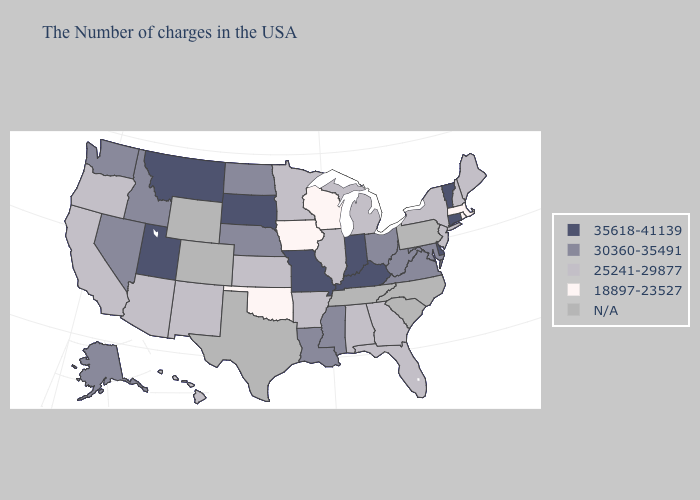Name the states that have a value in the range 35618-41139?
Quick response, please. Vermont, Connecticut, Delaware, Kentucky, Indiana, Missouri, South Dakota, Utah, Montana. Name the states that have a value in the range N/A?
Write a very short answer. Pennsylvania, North Carolina, South Carolina, Tennessee, Texas, Wyoming, Colorado. Does the map have missing data?
Keep it brief. Yes. Name the states that have a value in the range 35618-41139?
Short answer required. Vermont, Connecticut, Delaware, Kentucky, Indiana, Missouri, South Dakota, Utah, Montana. Which states have the highest value in the USA?
Quick response, please. Vermont, Connecticut, Delaware, Kentucky, Indiana, Missouri, South Dakota, Utah, Montana. Among the states that border New Hampshire , does Maine have the lowest value?
Keep it brief. No. Does Montana have the lowest value in the West?
Answer briefly. No. What is the value of Tennessee?
Be succinct. N/A. What is the value of Idaho?
Concise answer only. 30360-35491. Does South Dakota have the highest value in the MidWest?
Keep it brief. Yes. What is the value of Pennsylvania?
Keep it brief. N/A. Does the first symbol in the legend represent the smallest category?
Answer briefly. No. Which states hav the highest value in the Northeast?
Be succinct. Vermont, Connecticut. Which states hav the highest value in the MidWest?
Concise answer only. Indiana, Missouri, South Dakota. Among the states that border Kentucky , does Illinois have the lowest value?
Give a very brief answer. Yes. 